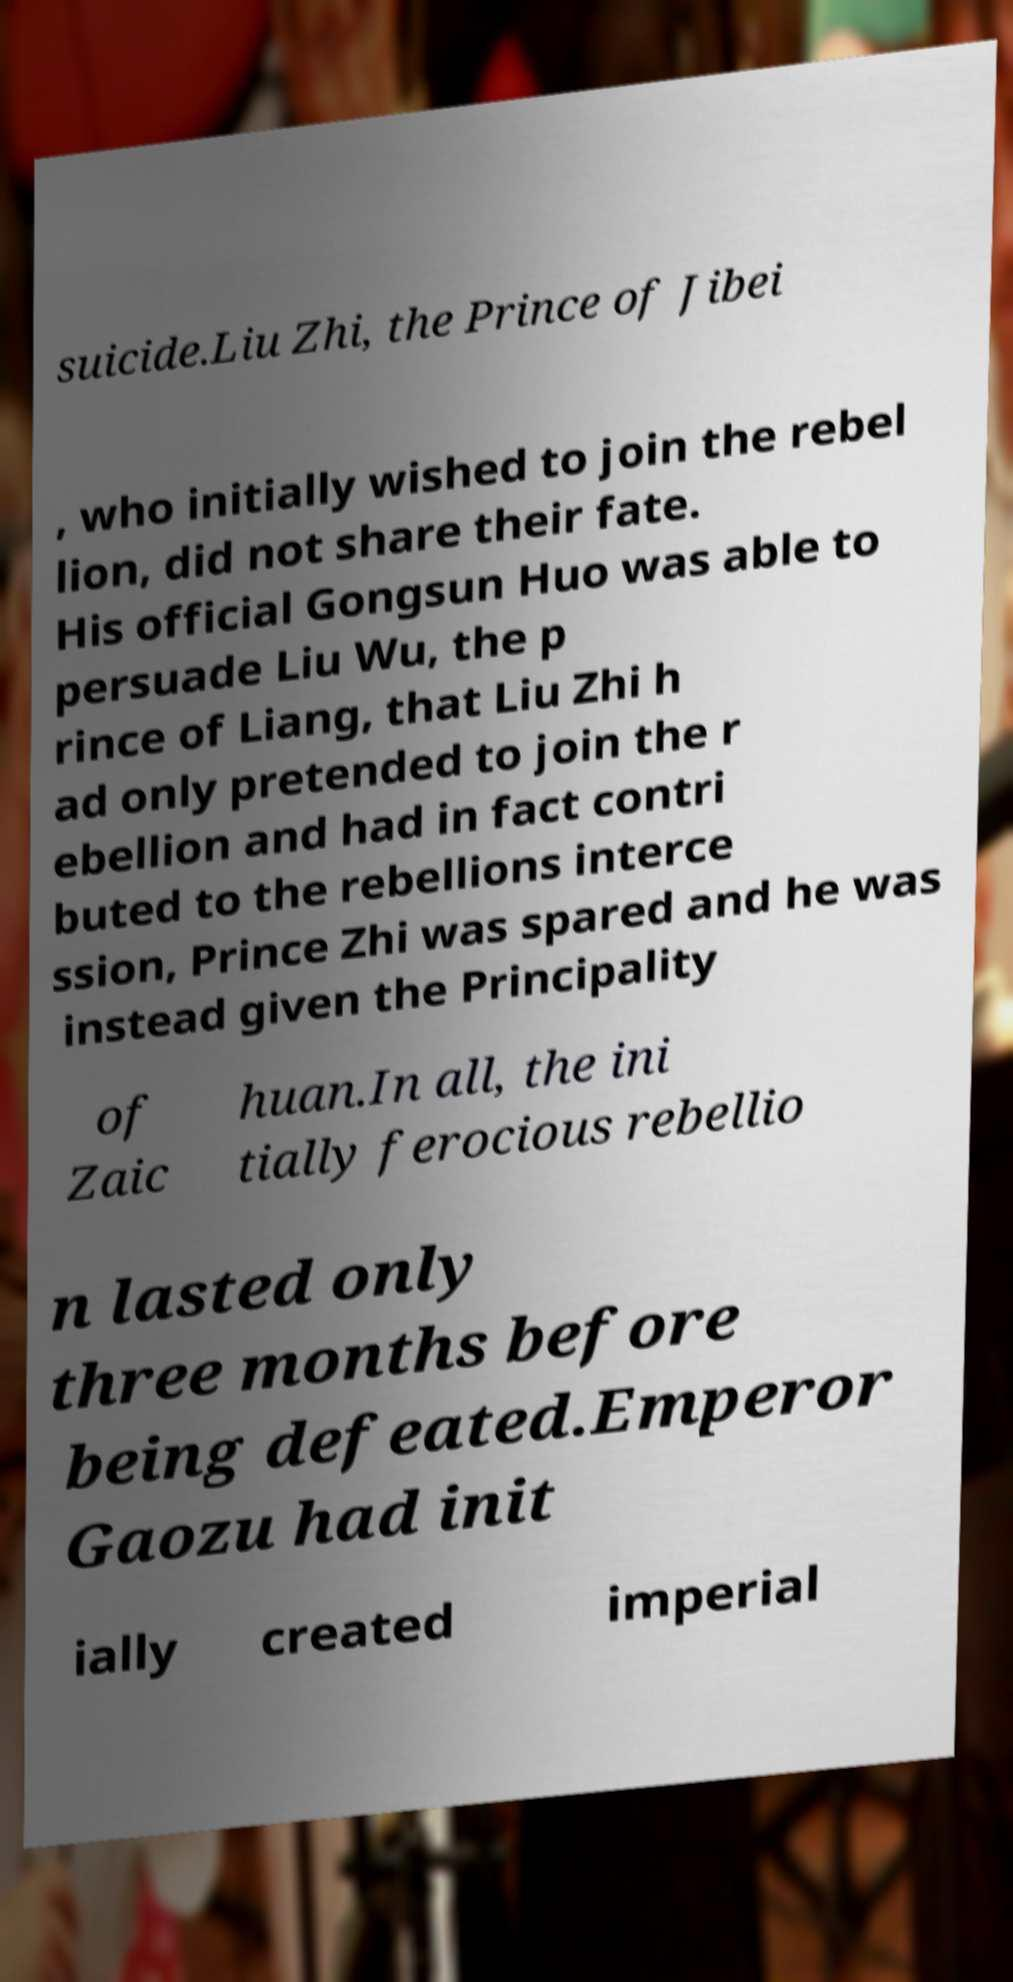What messages or text are displayed in this image? I need them in a readable, typed format. suicide.Liu Zhi, the Prince of Jibei , who initially wished to join the rebel lion, did not share their fate. His official Gongsun Huo was able to persuade Liu Wu, the p rince of Liang, that Liu Zhi h ad only pretended to join the r ebellion and had in fact contri buted to the rebellions interce ssion, Prince Zhi was spared and he was instead given the Principality of Zaic huan.In all, the ini tially ferocious rebellio n lasted only three months before being defeated.Emperor Gaozu had init ially created imperial 